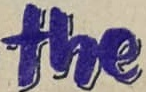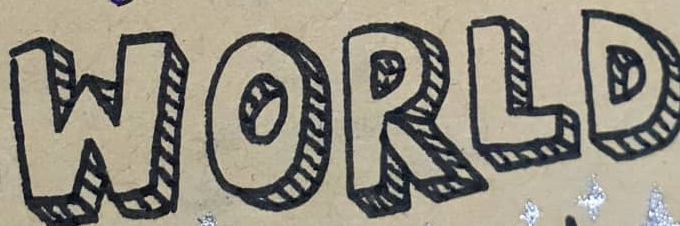What words are shown in these images in order, separated by a semicolon? the; WORLD 